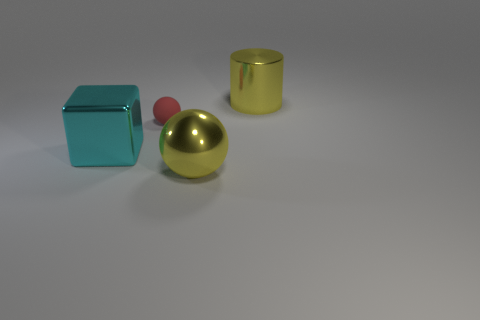Is the number of red spheres on the left side of the small red rubber sphere greater than the number of large things?
Give a very brief answer. No. There is a large yellow object that is to the left of the large yellow metallic cylinder; what is it made of?
Make the answer very short. Metal. The large thing that is the same shape as the tiny red thing is what color?
Your response must be concise. Yellow. How many big objects have the same color as the small sphere?
Ensure brevity in your answer.  0. Do the yellow shiny object behind the small thing and the sphere that is behind the big cyan thing have the same size?
Your answer should be compact. No. There is a cylinder; is it the same size as the ball that is to the left of the yellow metallic sphere?
Offer a very short reply. No. How big is the cyan metallic thing?
Your answer should be compact. Large. What is the color of the cylinder that is made of the same material as the big block?
Give a very brief answer. Yellow. How many things are the same material as the large yellow cylinder?
Give a very brief answer. 2. How many objects are red blocks or big yellow things that are on the left side of the big yellow cylinder?
Provide a short and direct response. 1. 